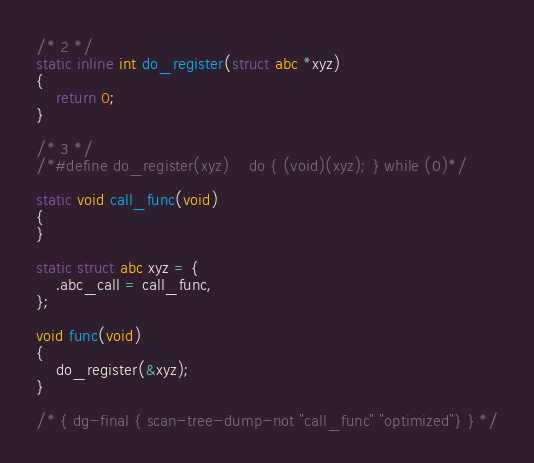Convert code to text. <code><loc_0><loc_0><loc_500><loc_500><_C_>/* 2 */
static inline int do_register(struct abc *xyz)
{
    return 0;
}

/* 3 */
/*#define do_register(xyz)    do { (void)(xyz); } while (0)*/

static void call_func(void)
{
}

static struct abc xyz = {
    .abc_call = call_func,
};

void func(void)
{
    do_register(&xyz);
}

/* { dg-final { scan-tree-dump-not "call_func" "optimized"} } */
</code> 